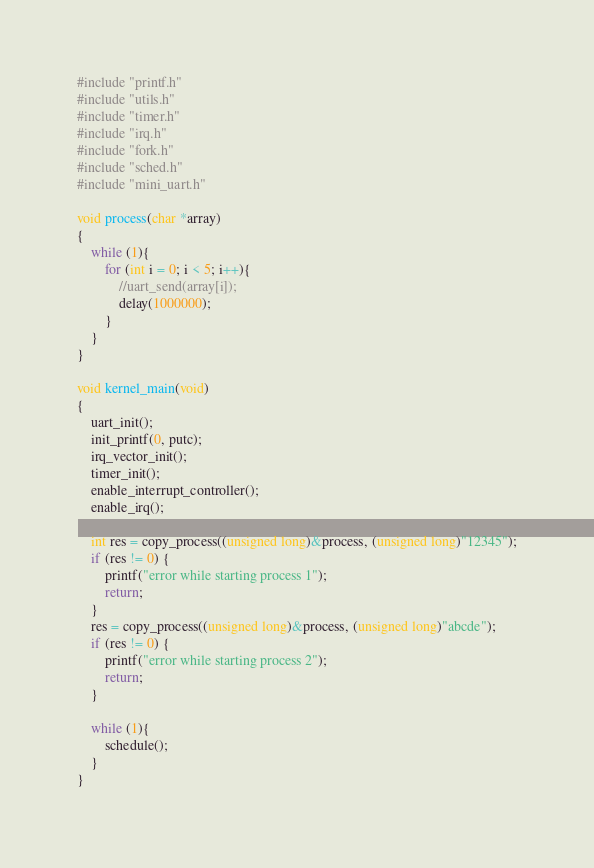<code> <loc_0><loc_0><loc_500><loc_500><_C_>#include "printf.h"
#include "utils.h"
#include "timer.h"
#include "irq.h"
#include "fork.h"
#include "sched.h"
#include "mini_uart.h"

void process(char *array)
{
	while (1){
		for (int i = 0; i < 5; i++){
			//uart_send(array[i]);
			delay(1000000);
		}
	}
}

void kernel_main(void)
{
	uart_init();
	init_printf(0, putc);
	irq_vector_init();
	timer_init();
	enable_interrupt_controller();
	enable_irq();

	int res = copy_process((unsigned long)&process, (unsigned long)"12345");
	if (res != 0) {
		printf("error while starting process 1");
		return;
	}
	res = copy_process((unsigned long)&process, (unsigned long)"abcde");
	if (res != 0) {
		printf("error while starting process 2");
		return;
	}

	while (1){
		schedule();
	}	
}
</code> 